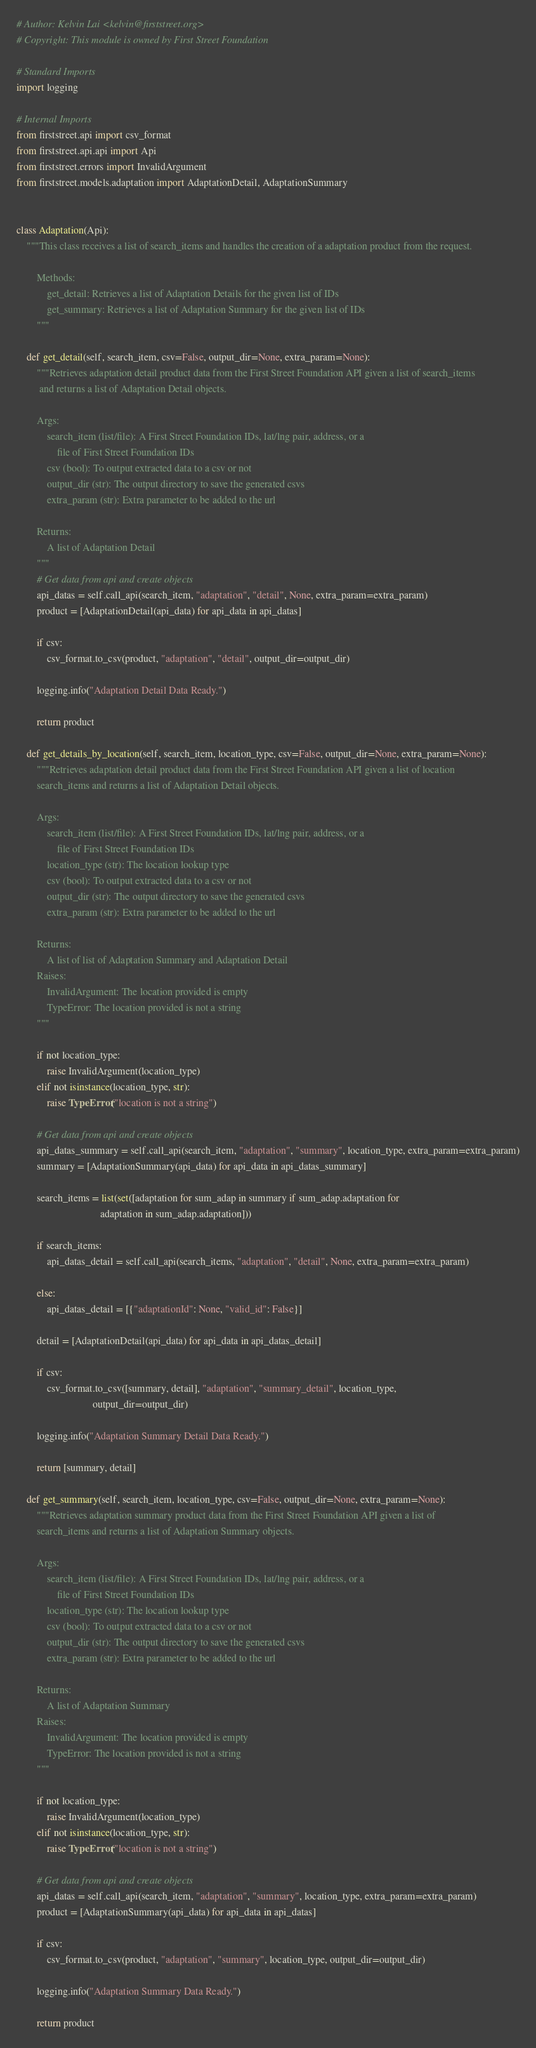Convert code to text. <code><loc_0><loc_0><loc_500><loc_500><_Python_># Author: Kelvin Lai <kelvin@firststreet.org>
# Copyright: This module is owned by First Street Foundation

# Standard Imports
import logging

# Internal Imports
from firststreet.api import csv_format
from firststreet.api.api import Api
from firststreet.errors import InvalidArgument
from firststreet.models.adaptation import AdaptationDetail, AdaptationSummary


class Adaptation(Api):
    """This class receives a list of search_items and handles the creation of a adaptation product from the request.

        Methods:
            get_detail: Retrieves a list of Adaptation Details for the given list of IDs
            get_summary: Retrieves a list of Adaptation Summary for the given list of IDs
        """

    def get_detail(self, search_item, csv=False, output_dir=None, extra_param=None):
        """Retrieves adaptation detail product data from the First Street Foundation API given a list of search_items
         and returns a list of Adaptation Detail objects.

        Args:
            search_item (list/file): A First Street Foundation IDs, lat/lng pair, address, or a
                file of First Street Foundation IDs
            csv (bool): To output extracted data to a csv or not
            output_dir (str): The output directory to save the generated csvs
            extra_param (str): Extra parameter to be added to the url

        Returns:
            A list of Adaptation Detail
        """
        # Get data from api and create objects
        api_datas = self.call_api(search_item, "adaptation", "detail", None, extra_param=extra_param)
        product = [AdaptationDetail(api_data) for api_data in api_datas]

        if csv:
            csv_format.to_csv(product, "adaptation", "detail", output_dir=output_dir)

        logging.info("Adaptation Detail Data Ready.")

        return product

    def get_details_by_location(self, search_item, location_type, csv=False, output_dir=None, extra_param=None):
        """Retrieves adaptation detail product data from the First Street Foundation API given a list of location
        search_items and returns a list of Adaptation Detail objects.

        Args:
            search_item (list/file): A First Street Foundation IDs, lat/lng pair, address, or a
                file of First Street Foundation IDs
            location_type (str): The location lookup type
            csv (bool): To output extracted data to a csv or not
            output_dir (str): The output directory to save the generated csvs
            extra_param (str): Extra parameter to be added to the url

        Returns:
            A list of list of Adaptation Summary and Adaptation Detail
        Raises:
            InvalidArgument: The location provided is empty
            TypeError: The location provided is not a string
        """

        if not location_type:
            raise InvalidArgument(location_type)
        elif not isinstance(location_type, str):
            raise TypeError("location is not a string")

        # Get data from api and create objects
        api_datas_summary = self.call_api(search_item, "adaptation", "summary", location_type, extra_param=extra_param)
        summary = [AdaptationSummary(api_data) for api_data in api_datas_summary]

        search_items = list(set([adaptation for sum_adap in summary if sum_adap.adaptation for
                                 adaptation in sum_adap.adaptation]))

        if search_items:
            api_datas_detail = self.call_api(search_items, "adaptation", "detail", None, extra_param=extra_param)

        else:
            api_datas_detail = [{"adaptationId": None, "valid_id": False}]

        detail = [AdaptationDetail(api_data) for api_data in api_datas_detail]

        if csv:
            csv_format.to_csv([summary, detail], "adaptation", "summary_detail", location_type,
                              output_dir=output_dir)

        logging.info("Adaptation Summary Detail Data Ready.")

        return [summary, detail]

    def get_summary(self, search_item, location_type, csv=False, output_dir=None, extra_param=None):
        """Retrieves adaptation summary product data from the First Street Foundation API given a list of
        search_items and returns a list of Adaptation Summary objects.

        Args:
            search_item (list/file): A First Street Foundation IDs, lat/lng pair, address, or a
                file of First Street Foundation IDs
            location_type (str): The location lookup type
            csv (bool): To output extracted data to a csv or not
            output_dir (str): The output directory to save the generated csvs
            extra_param (str): Extra parameter to be added to the url

        Returns:
            A list of Adaptation Summary
        Raises:
            InvalidArgument: The location provided is empty
            TypeError: The location provided is not a string
        """

        if not location_type:
            raise InvalidArgument(location_type)
        elif not isinstance(location_type, str):
            raise TypeError("location is not a string")

        # Get data from api and create objects
        api_datas = self.call_api(search_item, "adaptation", "summary", location_type, extra_param=extra_param)
        product = [AdaptationSummary(api_data) for api_data in api_datas]

        if csv:
            csv_format.to_csv(product, "adaptation", "summary", location_type, output_dir=output_dir)

        logging.info("Adaptation Summary Data Ready.")

        return product
</code> 